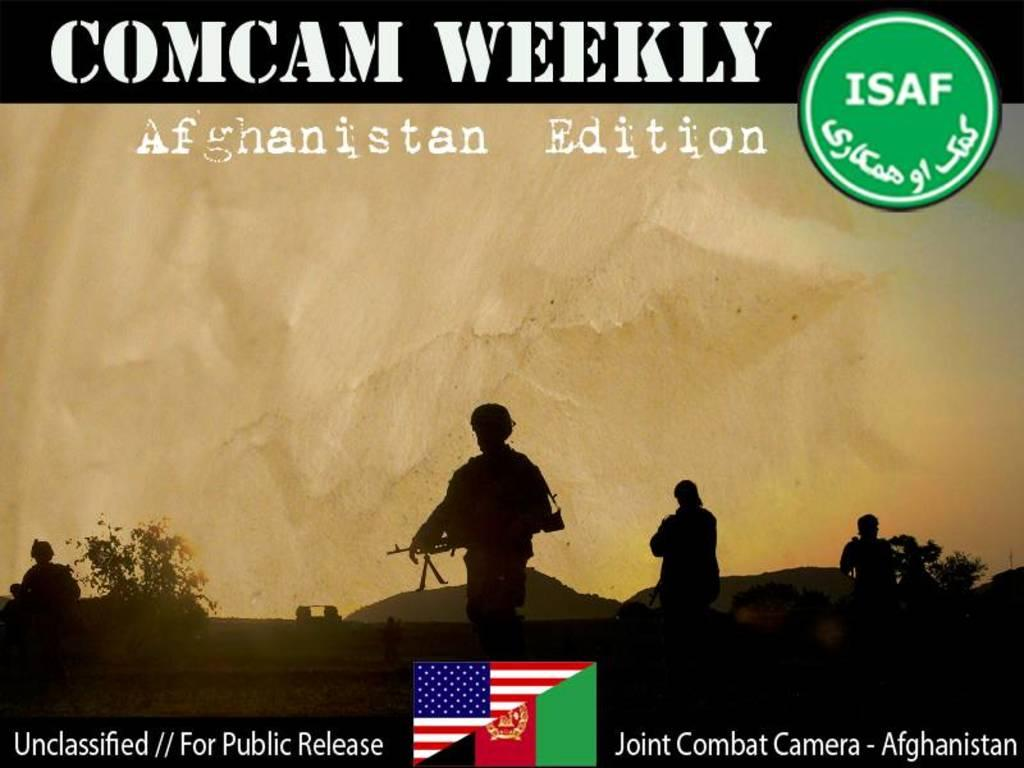<image>
Give a short and clear explanation of the subsequent image. A publication called Comcam Weekly with a solider on it 